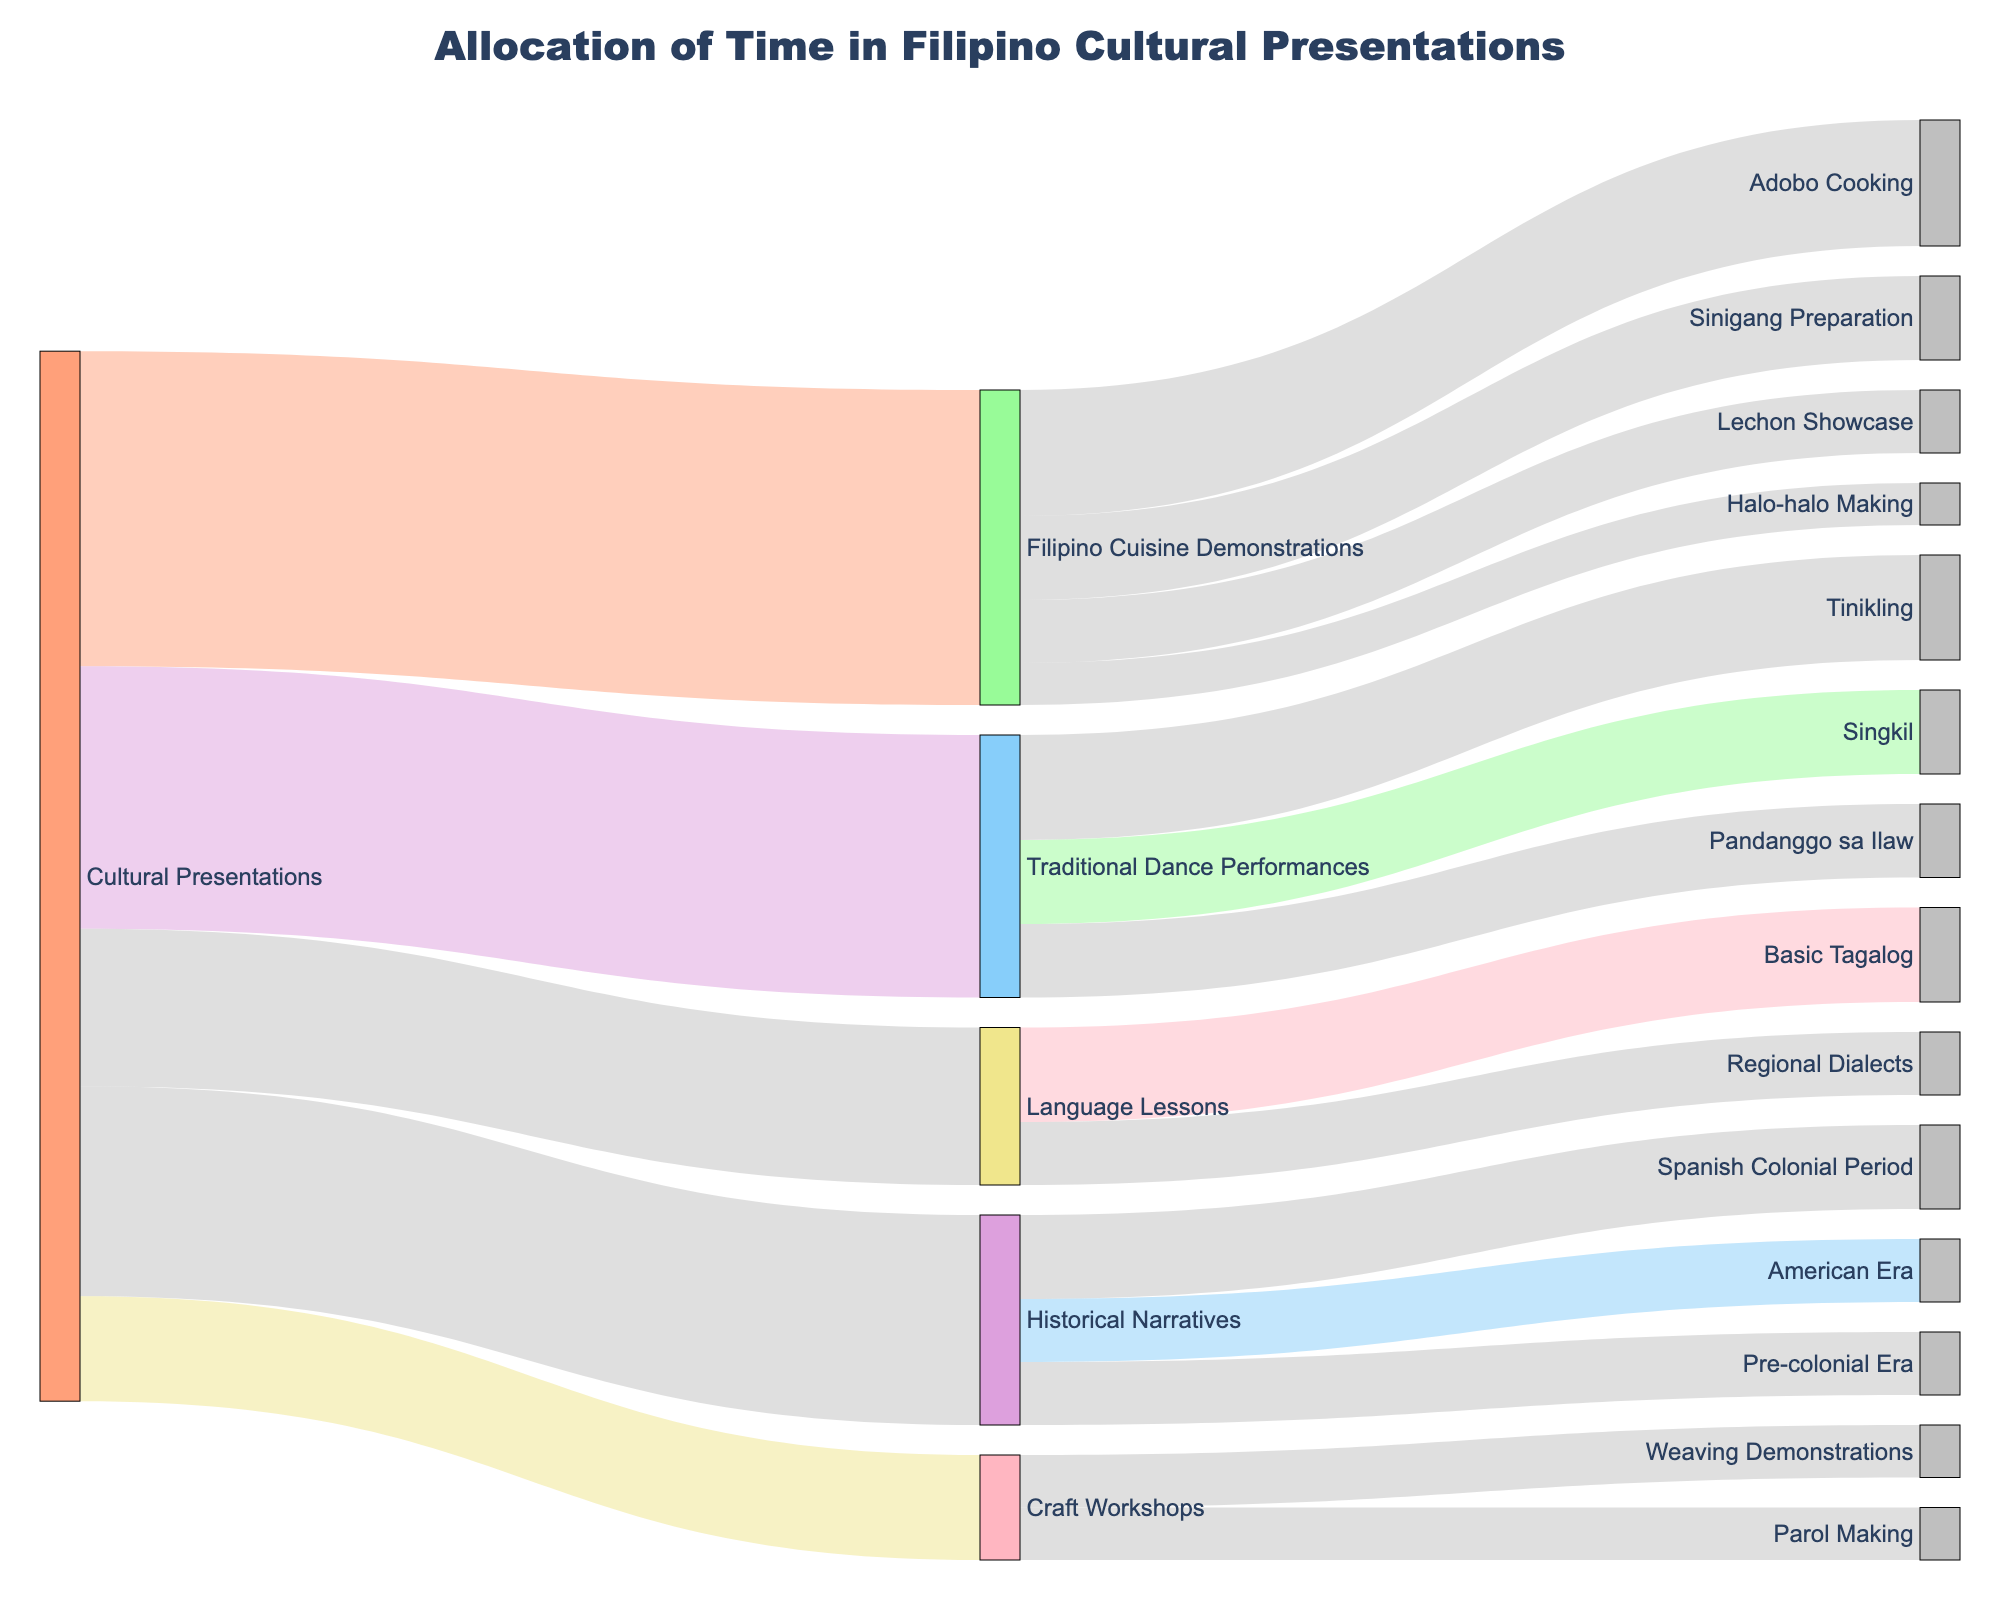What is the primary focus of the cultural presentations? The primary flows from "Cultural Presentations" show us how time is allocated among different aspects. The flows indicate that the presentations cover multiple areas, including Filipino Cuisine Demonstrations, Traditional Dance Performances, Historical Narratives, Language Lessons, and Craft Workshops.
Answer: Various aspects like cuisine, dance, history, language, and crafts Which category under Cultural Presentations receives the most time? The longest flow from "Cultural Presentations" shows the allocation of time. The flow to "Filipino Cuisine Demonstrations" is the longest, indicating this category receives the most time.
Answer: Filipino Cuisine Demonstrations How much time is spent on Traditional Dance Performances compared to Language Lessons? By comparing the flows from "Cultural Presentations" to "Traditional Dance Performances" and "Language Lessons", we see that "Traditional Dance Performances" has a flow of 25 and "Language Lessons" has a flow of 15. Subtracting these values, we get the difference.
Answer: 10 more on Dance How is the time allocated within Filipino Cuisine Demonstrations? The flows branching from "Filipino Cuisine Demonstrations" show allocations to specific demonstrations, like Adobo Cooking, Sinigang Preparation, Lechon Showcase, and Halo-halo Making. Summing these allocations gives us the total. Adobo Cooking gets the most at 12, followed by Sinigang Preparation at 8, Lechon Showcase at 6, and Halo-halo Making at 4.
Answer: Adobo: 12, Sinigang: 8, Lechon: 6, Halo-halo: 4 What is the combined time spent on Craft Workshops? The flows extending from "Cultural Presentations" to "Craft Workshops" show 10 units. The flows from "Craft Workshops" to specific activities show 5 units each for Weaving Demonstrations and Parol Making. Adding these values gives us the total.
Answer: 10 Which is the least focused activity among all the subcategories? By examining all the flows from the second level (subcategories under main categories), "Halo-halo Making" has the smallest flow with a value of 4.
Answer: Halo-halo Making How much time is dedicated to Historical Narratives about the Spanish Colonial Period? The flow from "Historical Narratives" to "Spanish Colonial Period" shows the specific time allocation. Looking at this flow, the value is 8.
Answer: 8 What is the total time allocated to the Pre-colonial Era and American Era segments of Historical Narratives? The flows from "Historical Narratives" to "Pre-colonial Era" and "American Era" show time allocations of 6 units each. Adding these gives a combined total.
Answer: 12 Compare the time spent on Language Lessons vs. Craft Workshops. The flows from "Cultural Presentations" to "Language Lessons" and "Craft Workshops" show values of 15 and 10 respectively. Comparison reveals that Language Lessons have more time.
Answer: Language Lessons more by 5 What are the main activities showcased in the Traditional Dance Performances? The flows from "Traditional Dance Performances" branch out to different types of dances like Tinikling, Singkil, and Pandanggo sa Ilaw. The values are 10, 8, and 7 respectively.
Answer: Tinikling: 10, Singkil: 8, Pandanggo sa Ilaw: 7 